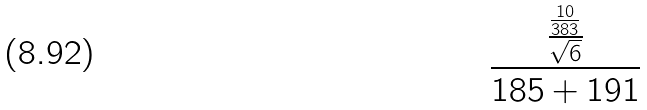Convert formula to latex. <formula><loc_0><loc_0><loc_500><loc_500>\frac { \frac { \frac { 1 0 } { 3 8 3 } } { \sqrt { 6 } } } { 1 8 5 + 1 9 1 }</formula> 